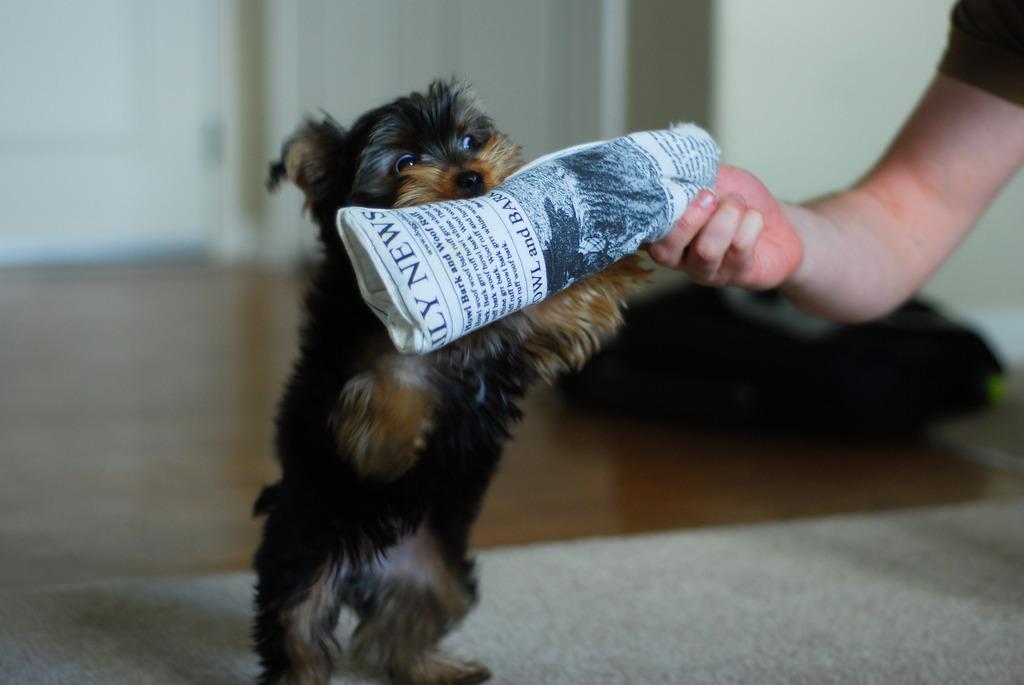In one or two sentences, can you explain what this image depicts? In the image we can see there is a dog standing and holding newspaper in his mouth. There is a person holding newspaper in his hand. 